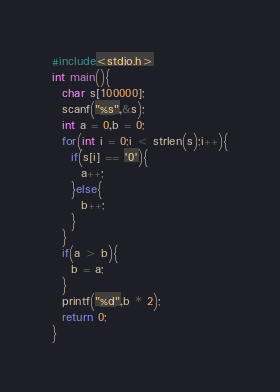<code> <loc_0><loc_0><loc_500><loc_500><_C_>#include<stdio.h>
int main(){
  char s[100000];
  scanf("%s",&s);
  int a = 0,b = 0;
  for(int i = 0;i < strlen(s);i++){
    if(s[i] == '0'){
      a++;
    }else{
      b++;
    }
  }
  if(a > b){
    b = a;
  }
  printf("%d",b * 2);
  return 0;
}</code> 